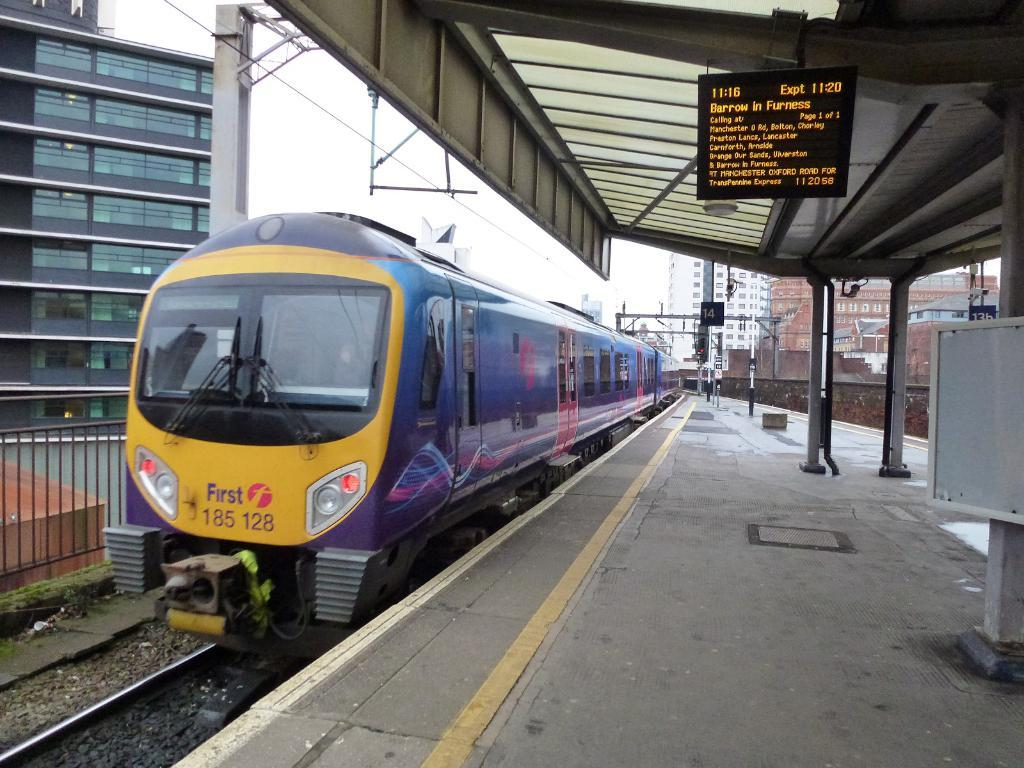<image>
Offer a succinct explanation of the picture presented. A yellow train that says First on the front of it. 